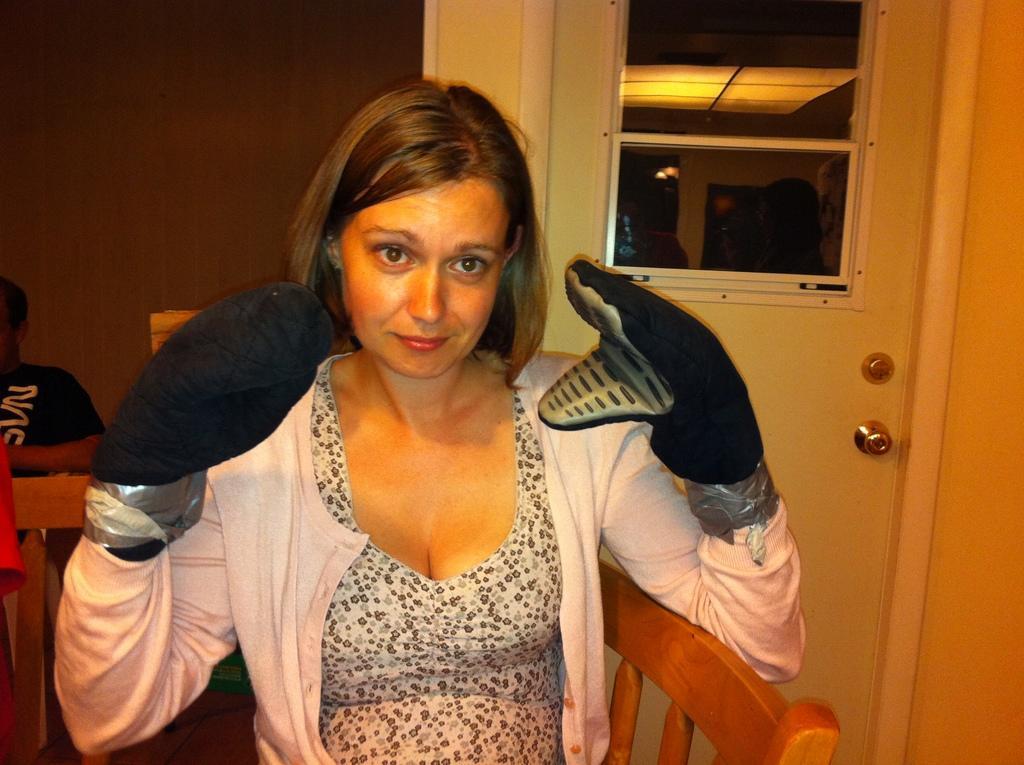In one or two sentences, can you explain what this image depicts? In this picture, we see a woman who is wearing the pink jacket and the gloves is sitting on the chair. She might be posing for the photo. Behind her, we see a man is sitting on the chair. On the right side, we see a white door. In the background, we see a wall which is brown in color. 